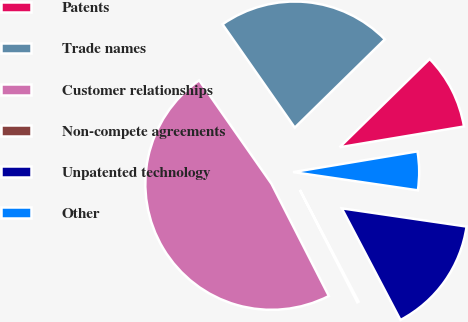<chart> <loc_0><loc_0><loc_500><loc_500><pie_chart><fcel>Patents<fcel>Trade names<fcel>Customer relationships<fcel>Non-compete agreements<fcel>Unpatented technology<fcel>Other<nl><fcel>9.71%<fcel>22.37%<fcel>47.81%<fcel>0.18%<fcel>14.99%<fcel>4.94%<nl></chart> 